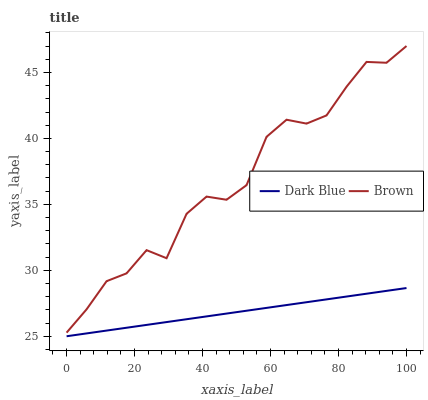Does Dark Blue have the minimum area under the curve?
Answer yes or no. Yes. Does Brown have the maximum area under the curve?
Answer yes or no. Yes. Does Brown have the minimum area under the curve?
Answer yes or no. No. Is Dark Blue the smoothest?
Answer yes or no. Yes. Is Brown the roughest?
Answer yes or no. Yes. Is Brown the smoothest?
Answer yes or no. No. Does Dark Blue have the lowest value?
Answer yes or no. Yes. Does Brown have the lowest value?
Answer yes or no. No. Does Brown have the highest value?
Answer yes or no. Yes. Is Dark Blue less than Brown?
Answer yes or no. Yes. Is Brown greater than Dark Blue?
Answer yes or no. Yes. Does Dark Blue intersect Brown?
Answer yes or no. No. 